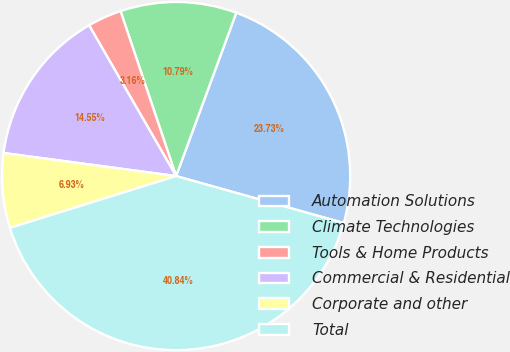<chart> <loc_0><loc_0><loc_500><loc_500><pie_chart><fcel>Automation Solutions<fcel>Climate Technologies<fcel>Tools & Home Products<fcel>Commercial & Residential<fcel>Corporate and other<fcel>Total<nl><fcel>23.73%<fcel>10.79%<fcel>3.16%<fcel>14.55%<fcel>6.93%<fcel>40.84%<nl></chart> 